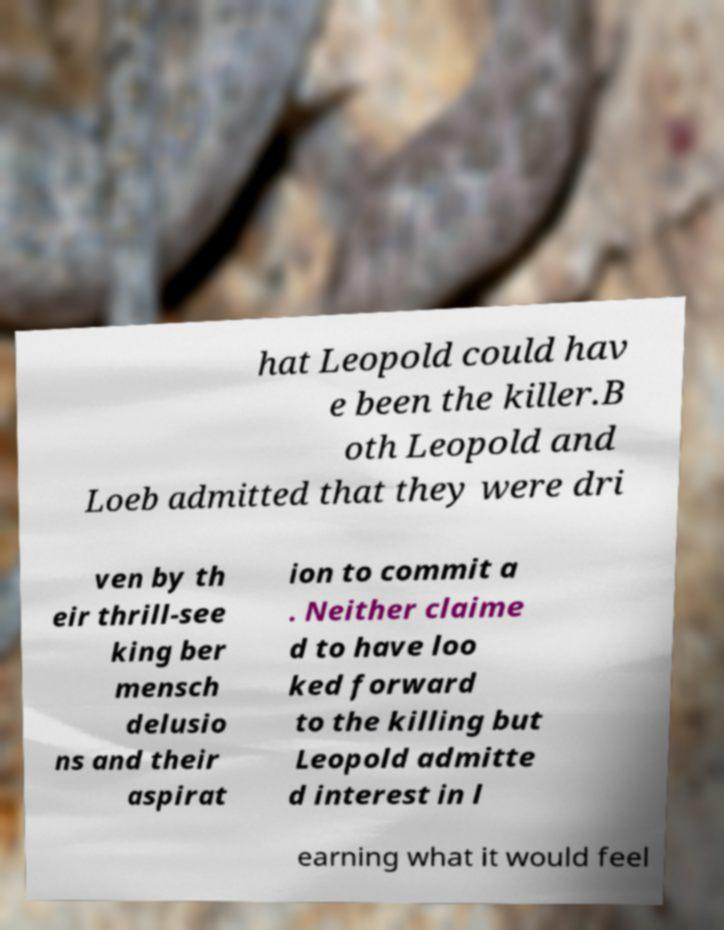Please read and relay the text visible in this image. What does it say? hat Leopold could hav e been the killer.B oth Leopold and Loeb admitted that they were dri ven by th eir thrill-see king ber mensch delusio ns and their aspirat ion to commit a . Neither claime d to have loo ked forward to the killing but Leopold admitte d interest in l earning what it would feel 